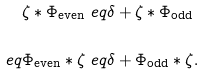Convert formula to latex. <formula><loc_0><loc_0><loc_500><loc_500>\zeta \ast \Phi _ { \text {even} } & \ e q \delta + \zeta \ast \Phi _ { \text {odd} } \\ \ e q \Phi _ { \text {even} } \ast \zeta & \ e q \delta + \Phi _ { \text {odd} } \ast \zeta .</formula> 